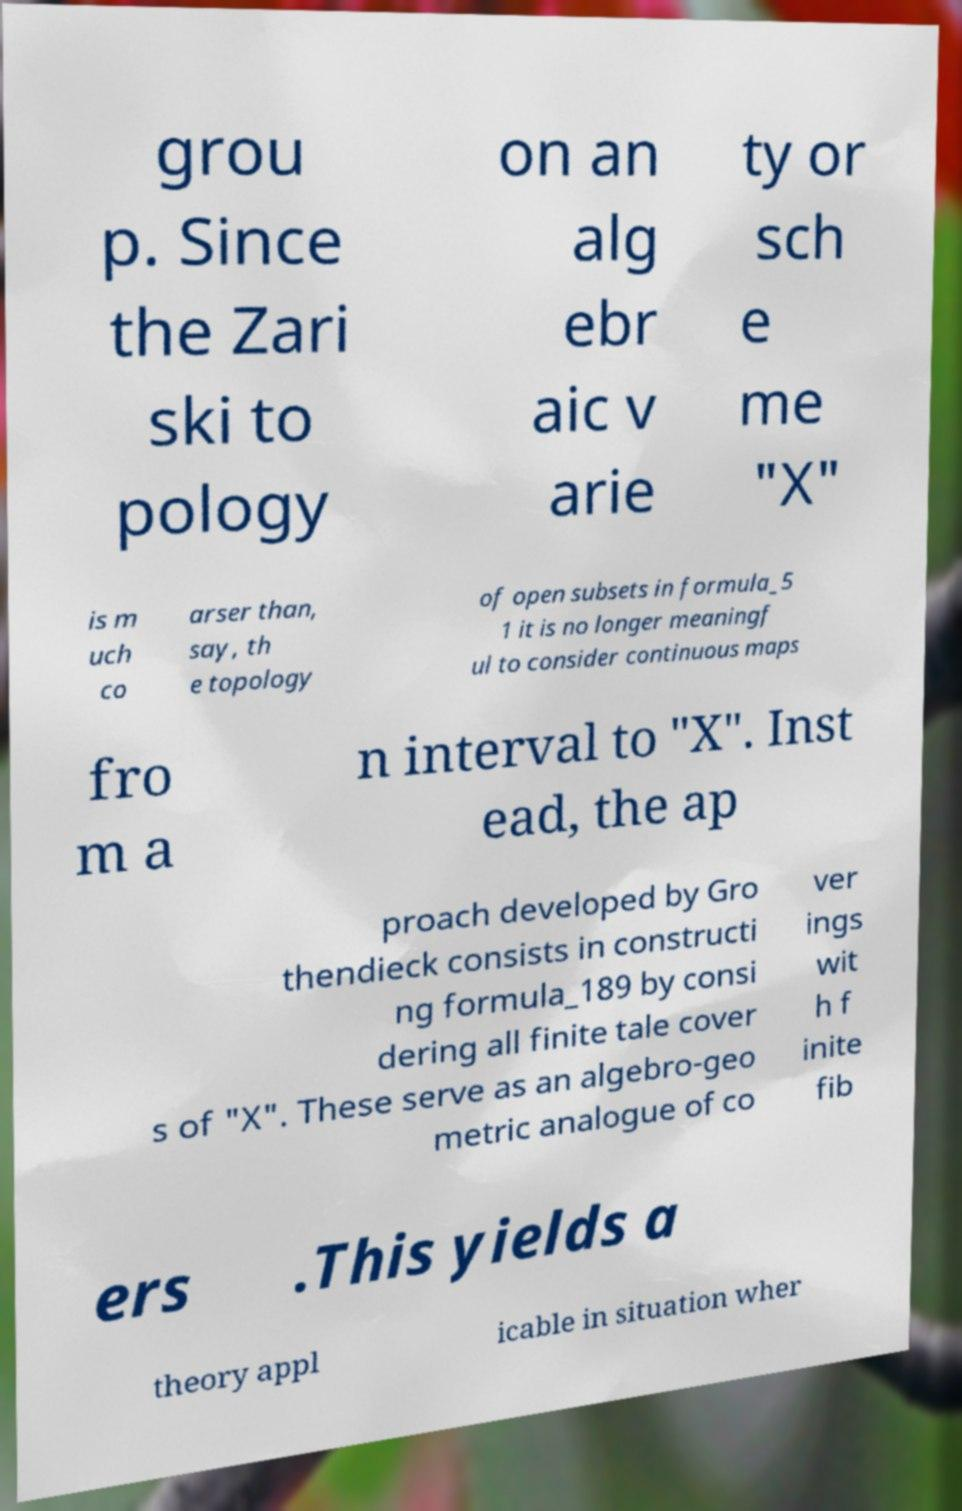Can you accurately transcribe the text from the provided image for me? grou p. Since the Zari ski to pology on an alg ebr aic v arie ty or sch e me "X" is m uch co arser than, say, th e topology of open subsets in formula_5 1 it is no longer meaningf ul to consider continuous maps fro m a n interval to "X". Inst ead, the ap proach developed by Gro thendieck consists in constructi ng formula_189 by consi dering all finite tale cover s of "X". These serve as an algebro-geo metric analogue of co ver ings wit h f inite fib ers .This yields a theory appl icable in situation wher 